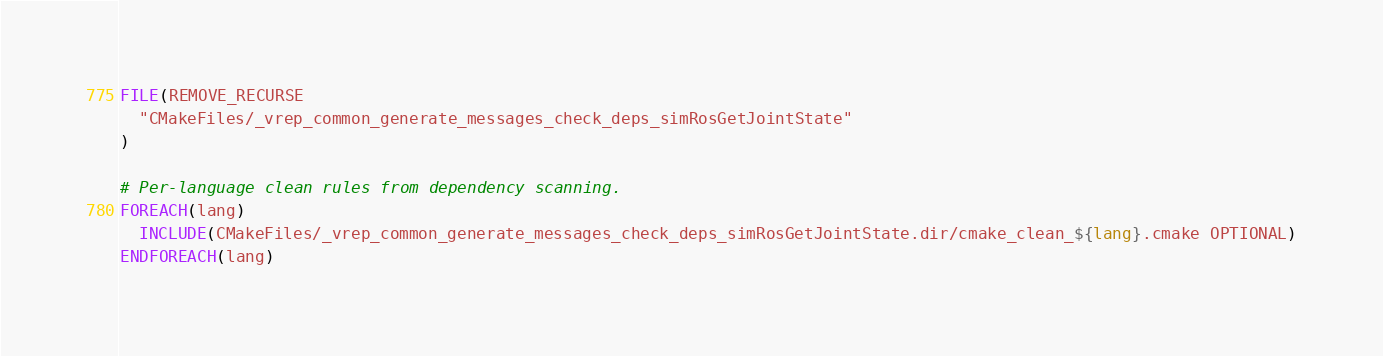Convert code to text. <code><loc_0><loc_0><loc_500><loc_500><_CMake_>FILE(REMOVE_RECURSE
  "CMakeFiles/_vrep_common_generate_messages_check_deps_simRosGetJointState"
)

# Per-language clean rules from dependency scanning.
FOREACH(lang)
  INCLUDE(CMakeFiles/_vrep_common_generate_messages_check_deps_simRosGetJointState.dir/cmake_clean_${lang}.cmake OPTIONAL)
ENDFOREACH(lang)
</code> 